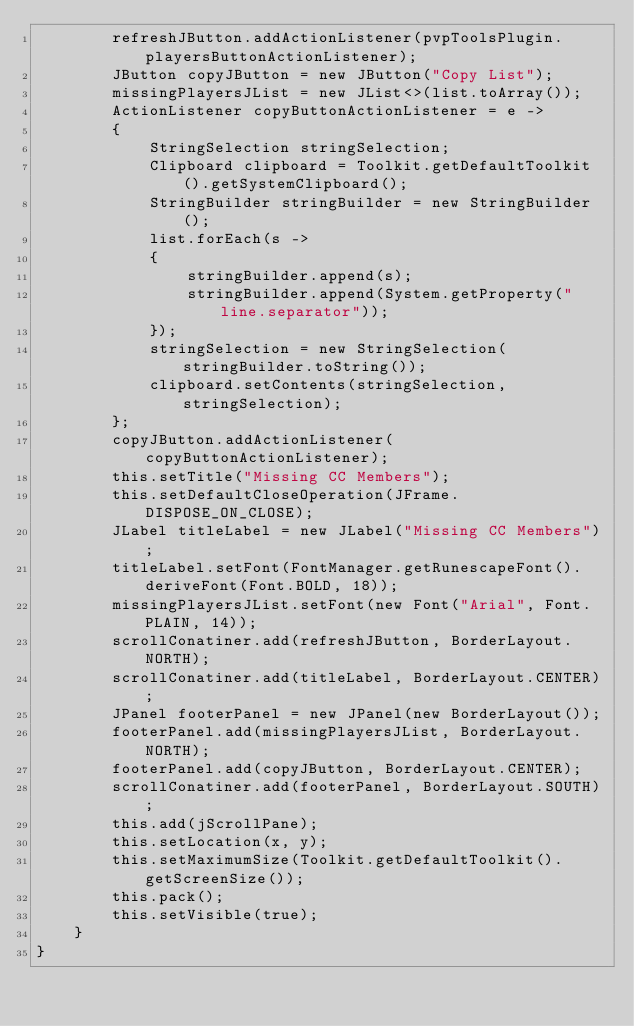Convert code to text. <code><loc_0><loc_0><loc_500><loc_500><_Java_>		refreshJButton.addActionListener(pvpToolsPlugin.playersButtonActionListener);
		JButton copyJButton = new JButton("Copy List");
		missingPlayersJList = new JList<>(list.toArray());
		ActionListener copyButtonActionListener = e ->
		{
			StringSelection stringSelection;
			Clipboard clipboard = Toolkit.getDefaultToolkit().getSystemClipboard();
			StringBuilder stringBuilder = new StringBuilder();
			list.forEach(s ->
			{
				stringBuilder.append(s);
				stringBuilder.append(System.getProperty("line.separator"));
			});
			stringSelection = new StringSelection(stringBuilder.toString());
			clipboard.setContents(stringSelection, stringSelection);
		};
		copyJButton.addActionListener(copyButtonActionListener);
		this.setTitle("Missing CC Members");
		this.setDefaultCloseOperation(JFrame.DISPOSE_ON_CLOSE);
		JLabel titleLabel = new JLabel("Missing CC Members");
		titleLabel.setFont(FontManager.getRunescapeFont().deriveFont(Font.BOLD, 18));
		missingPlayersJList.setFont(new Font("Arial", Font.PLAIN, 14));
		scrollConatiner.add(refreshJButton, BorderLayout.NORTH);
		scrollConatiner.add(titleLabel, BorderLayout.CENTER);
		JPanel footerPanel = new JPanel(new BorderLayout());
		footerPanel.add(missingPlayersJList, BorderLayout.NORTH);
		footerPanel.add(copyJButton, BorderLayout.CENTER);
		scrollConatiner.add(footerPanel, BorderLayout.SOUTH);
		this.add(jScrollPane);
		this.setLocation(x, y);
		this.setMaximumSize(Toolkit.getDefaultToolkit().getScreenSize());
		this.pack();
		this.setVisible(true);
	}
}
</code> 